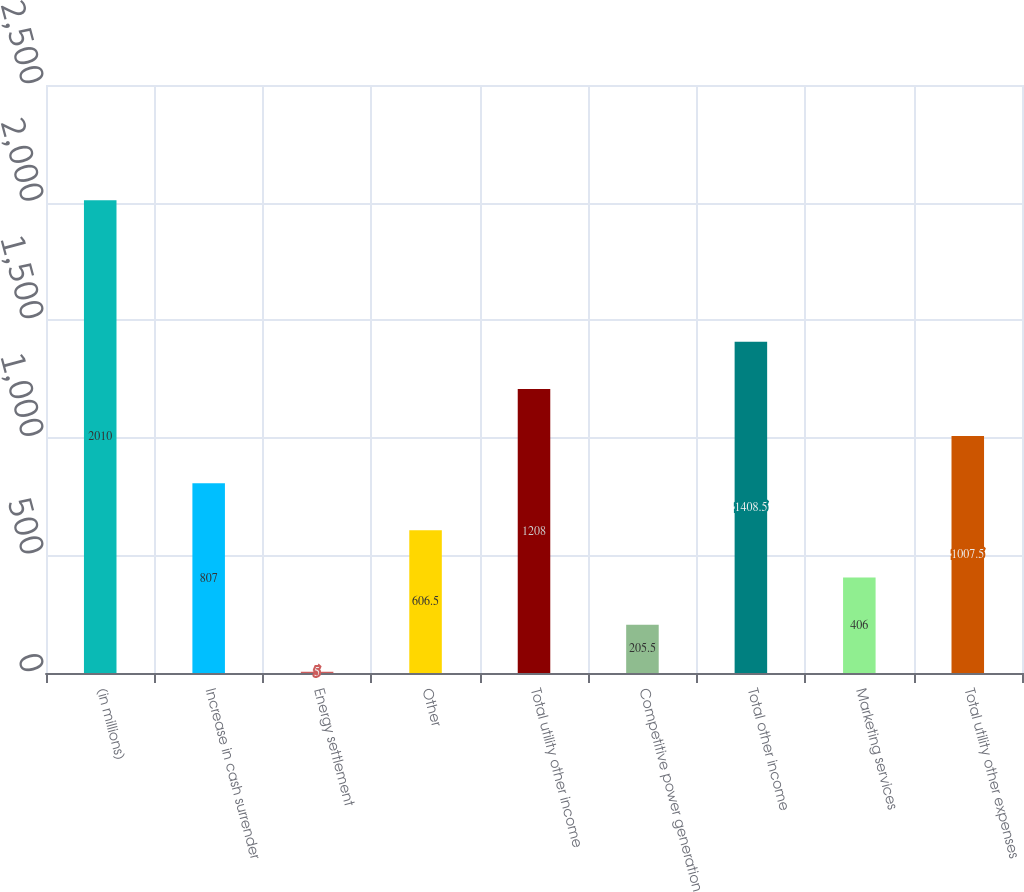Convert chart to OTSL. <chart><loc_0><loc_0><loc_500><loc_500><bar_chart><fcel>(in millions)<fcel>Increase in cash surrender<fcel>Energy settlement<fcel>Other<fcel>Total utility other income<fcel>Competitive power generation<fcel>Total other income<fcel>Marketing services<fcel>Total utility other expenses<nl><fcel>2010<fcel>807<fcel>5<fcel>606.5<fcel>1208<fcel>205.5<fcel>1408.5<fcel>406<fcel>1007.5<nl></chart> 